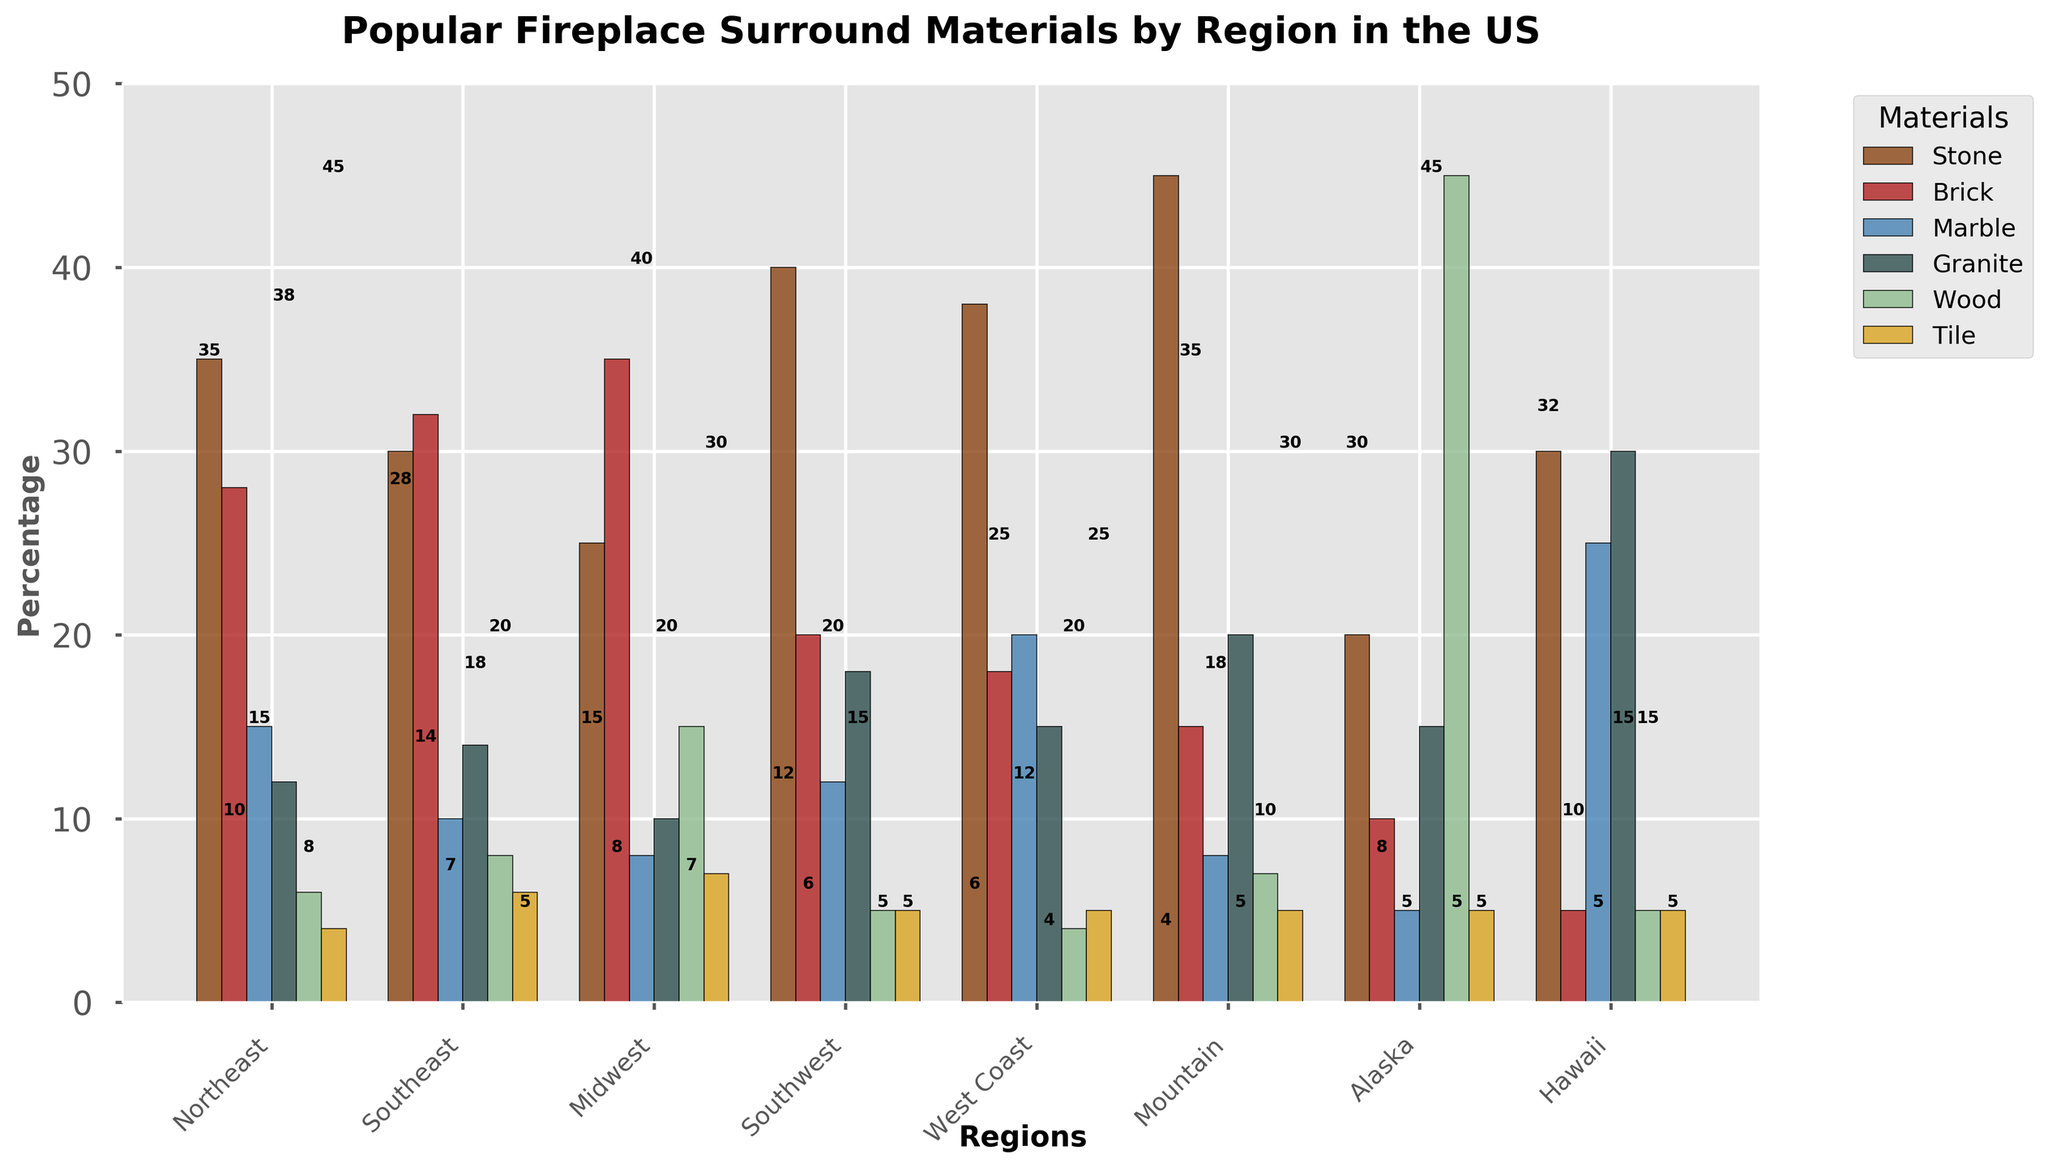Which region has the highest percentage of stone fireplace surrounds? By examining the height of the bars and the labels, we can see that the region with the highest percentage of stone fireplace surrounds is the Mountain region with a value of 45.
Answer: Mountain Which region has the least percentage of wood fireplace surrounds? By comparing the heights and labels of the bars representing wood fireplace surrounds, Alaska stands out with the least percentage, which is 5.
Answer: Alaska In which region is marble more popular than tile? By checking the height of the marble and tile bars in each region, marble is more popular than tile in Northeast, Southeast, Southwest, West Coast, Mountain, and Hawaii.
Answer: Northeast, Southeast, Southwest, West Coast, Mountain, Hawaii Which material is more popular in the Midwest: brick or wood? By comparing the height of the bars in the Midwest region for brick and wood, the brick bar is taller with a height of 35 compared to wood with 15.
Answer: Brick Sum up the percentage of tile fireplace surrounds in the West Coast and Mountain regions. By reading the heights of the bars for tile in both West Coast and Mountain, the values are 5 and 5 respectively. Summing these gives 5 + 5 = 10.
Answer: 10 Which region has the lowest percentage of marble fireplace surrounds? By evaluating the bar heights and labels indicating marble fireplace surrounds, Alaska has the lowest percentage with a value of 5.
Answer: Alaska What is the difference in the percentage of granite fireplace surrounds between the Southwest and Hawaii regions? Find the bar heights for granite in Southwest (18) and Hawaii (30), and calculate the difference 30 - 18 = 12.
Answer: 12 Which material is the third most popular in the Northeast? By comparing the bar heights in the Northeast region, the third highest bar represents marble with a value of 15.
Answer: Marble In how many regions is the percentage of stone fireplace surrounds greater than 35%? By counting the number of bars labeled stone that have heights greater than 35, there are three such regions: Southwest, West Coast, and Mountain.
Answer: 3 Compare the popularity of wood fireplace surrounds between the Southeast and Midwest regions. Viewing the heights of the wood bars, the Southeast has a percentage of 8 whereas the Midwest has a greater percentage of 15.
Answer: Midwest 